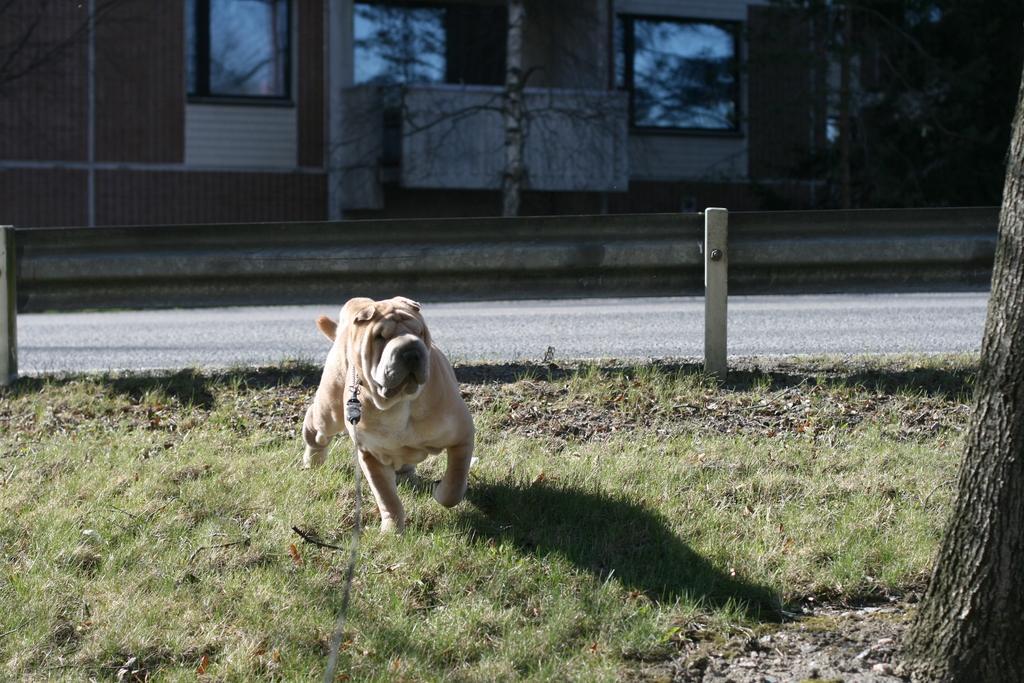Could you give a brief overview of what you see in this image? In this image I can see a dog is running in the grass, at the back side there is a house with windows. In the middle it looks like a road. 